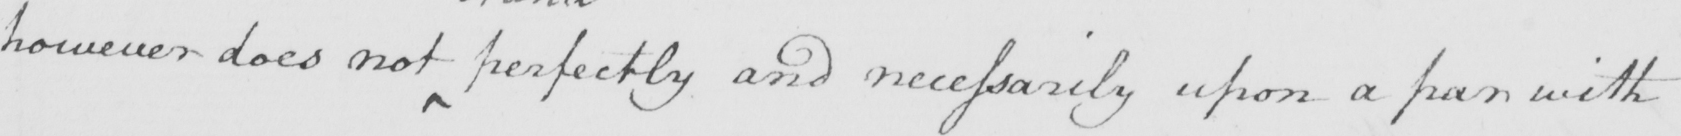What does this handwritten line say? however does not perfectly and necessarily upon a par with 